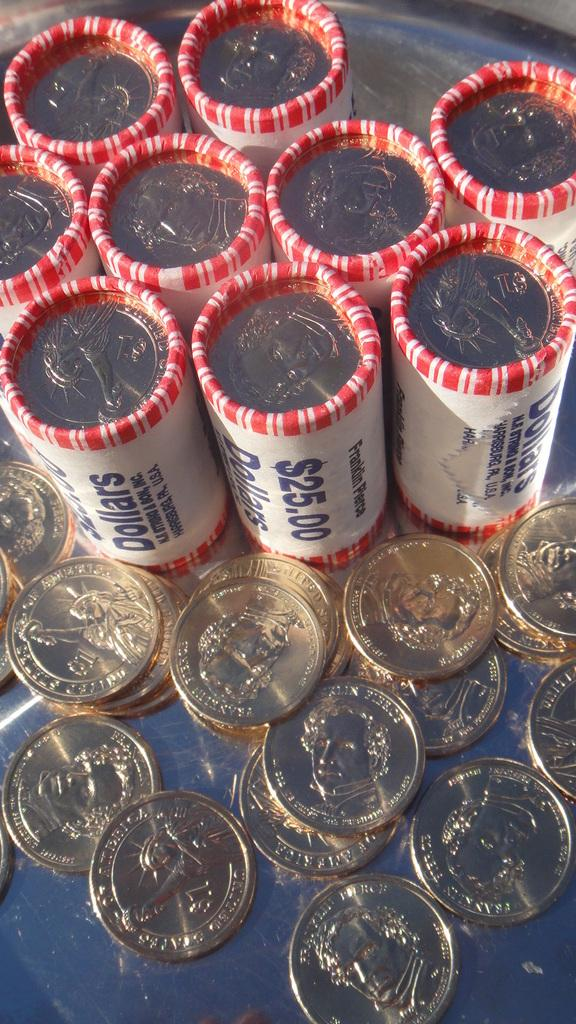What is located at the bottom of the image? There are coins at the bottom of the image. What can be seen in the center of the image? There are packets in the center of the image. What is inside the packets? The packets contain a group of coins. How much sugar is contained in the packets in the image? There is no sugar mentioned in the image; the packets contain a group of coins. What type of shock can be seen in the image? There is no shock present in the image; it features coins and packets. 